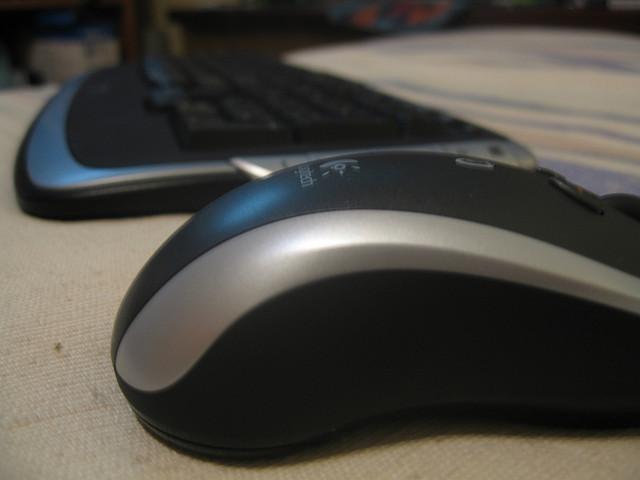What kind of fruit is on the mouse?
Short answer required. None. What type of mouse is this?
Concise answer only. Logitech. Can a phone number be dialed on the device shown?
Answer briefly. No. What colors are on the mouse?
Write a very short answer. Black and gray. Is the mouse wireless?
Answer briefly. Yes. What color is the mouse?
Keep it brief. Black and silver. 